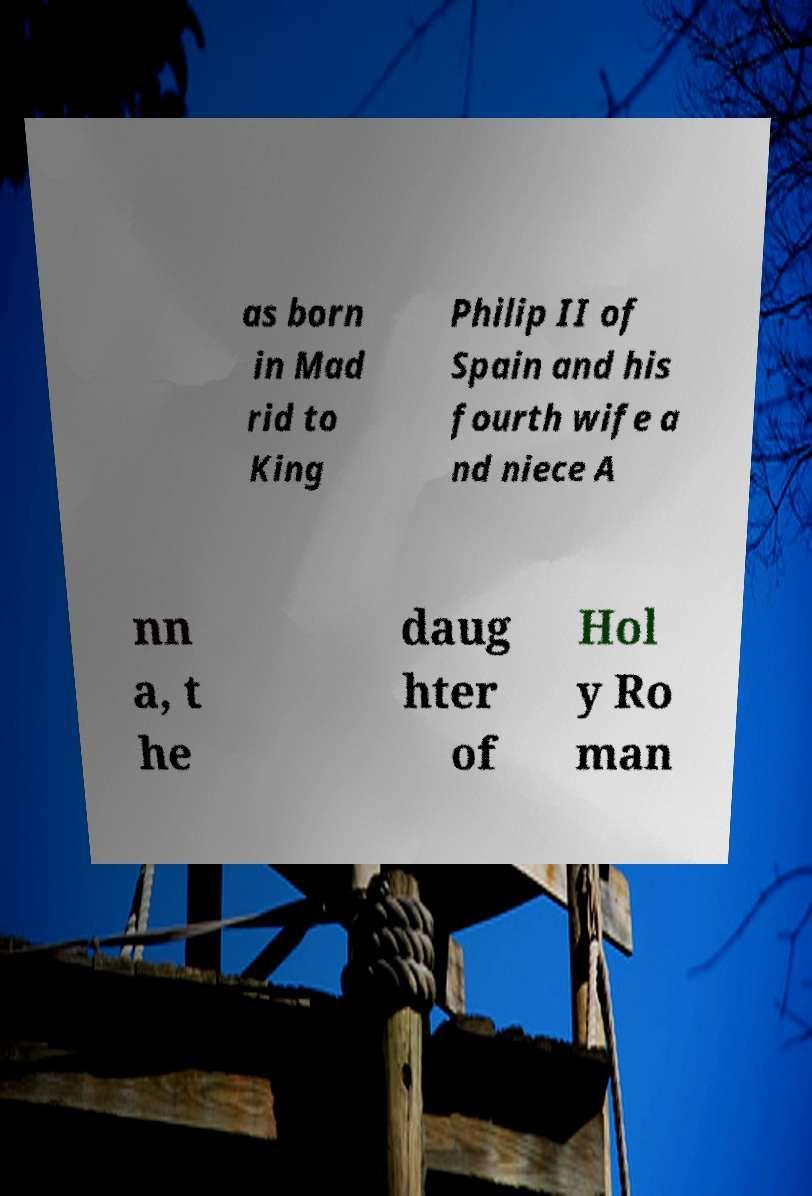For documentation purposes, I need the text within this image transcribed. Could you provide that? as born in Mad rid to King Philip II of Spain and his fourth wife a nd niece A nn a, t he daug hter of Hol y Ro man 